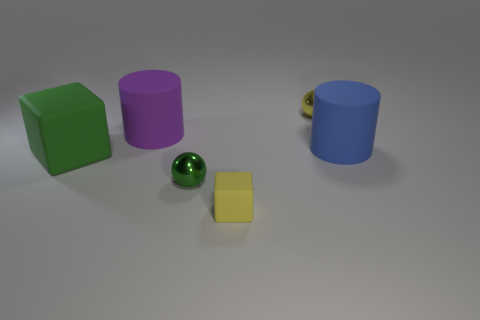Add 3 small yellow blocks. How many objects exist? 9 Subtract all cylinders. How many objects are left? 4 Subtract all big cylinders. Subtract all big matte things. How many objects are left? 1 Add 4 small spheres. How many small spheres are left? 6 Add 2 small yellow rubber objects. How many small yellow rubber objects exist? 3 Subtract 0 gray cylinders. How many objects are left? 6 